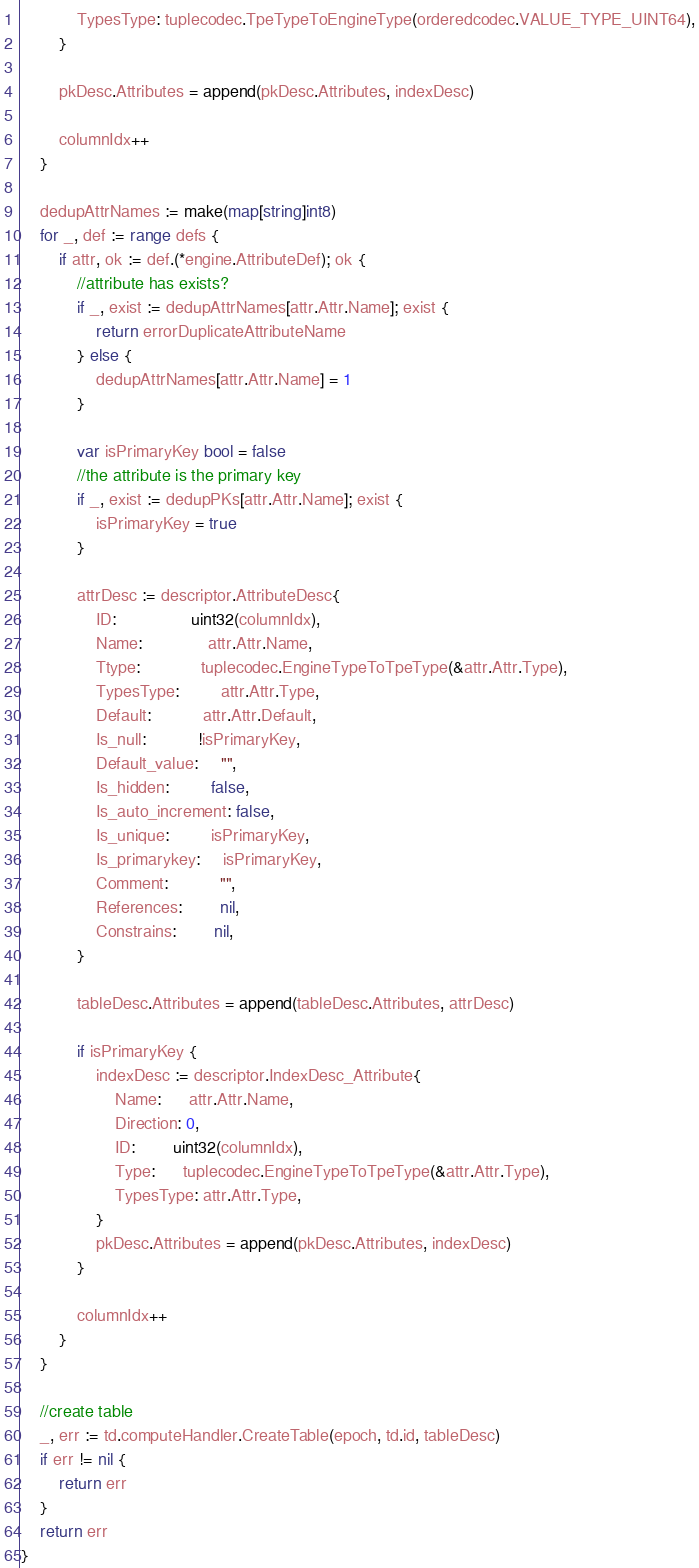<code> <loc_0><loc_0><loc_500><loc_500><_Go_>			TypesType: tuplecodec.TpeTypeToEngineType(orderedcodec.VALUE_TYPE_UINT64),
		}

		pkDesc.Attributes = append(pkDesc.Attributes, indexDesc)

		columnIdx++
	}

	dedupAttrNames := make(map[string]int8)
	for _, def := range defs {
		if attr, ok := def.(*engine.AttributeDef); ok {
			//attribute has exists?
			if _, exist := dedupAttrNames[attr.Attr.Name]; exist {
				return errorDuplicateAttributeName
			} else {
				dedupAttrNames[attr.Attr.Name] = 1
			}

			var isPrimaryKey bool = false
			//the attribute is the primary key
			if _, exist := dedupPKs[attr.Attr.Name]; exist {
				isPrimaryKey = true
			}

			attrDesc := descriptor.AttributeDesc{
				ID:                uint32(columnIdx),
				Name:              attr.Attr.Name,
				Ttype:             tuplecodec.EngineTypeToTpeType(&attr.Attr.Type),
				TypesType:         attr.Attr.Type,
				Default:           attr.Attr.Default,
				Is_null:           !isPrimaryKey,
				Default_value:     "",
				Is_hidden:         false,
				Is_auto_increment: false,
				Is_unique:         isPrimaryKey,
				Is_primarykey:     isPrimaryKey,
				Comment:           "",
				References:        nil,
				Constrains:        nil,
			}

			tableDesc.Attributes = append(tableDesc.Attributes, attrDesc)

			if isPrimaryKey {
				indexDesc := descriptor.IndexDesc_Attribute{
					Name:      attr.Attr.Name,
					Direction: 0,
					ID:        uint32(columnIdx),
					Type:      tuplecodec.EngineTypeToTpeType(&attr.Attr.Type),
					TypesType: attr.Attr.Type,
				}
				pkDesc.Attributes = append(pkDesc.Attributes, indexDesc)
			}

			columnIdx++
		}
	}

	//create table
	_, err := td.computeHandler.CreateTable(epoch, td.id, tableDesc)
	if err != nil {
		return err
	}
	return err
}
</code> 